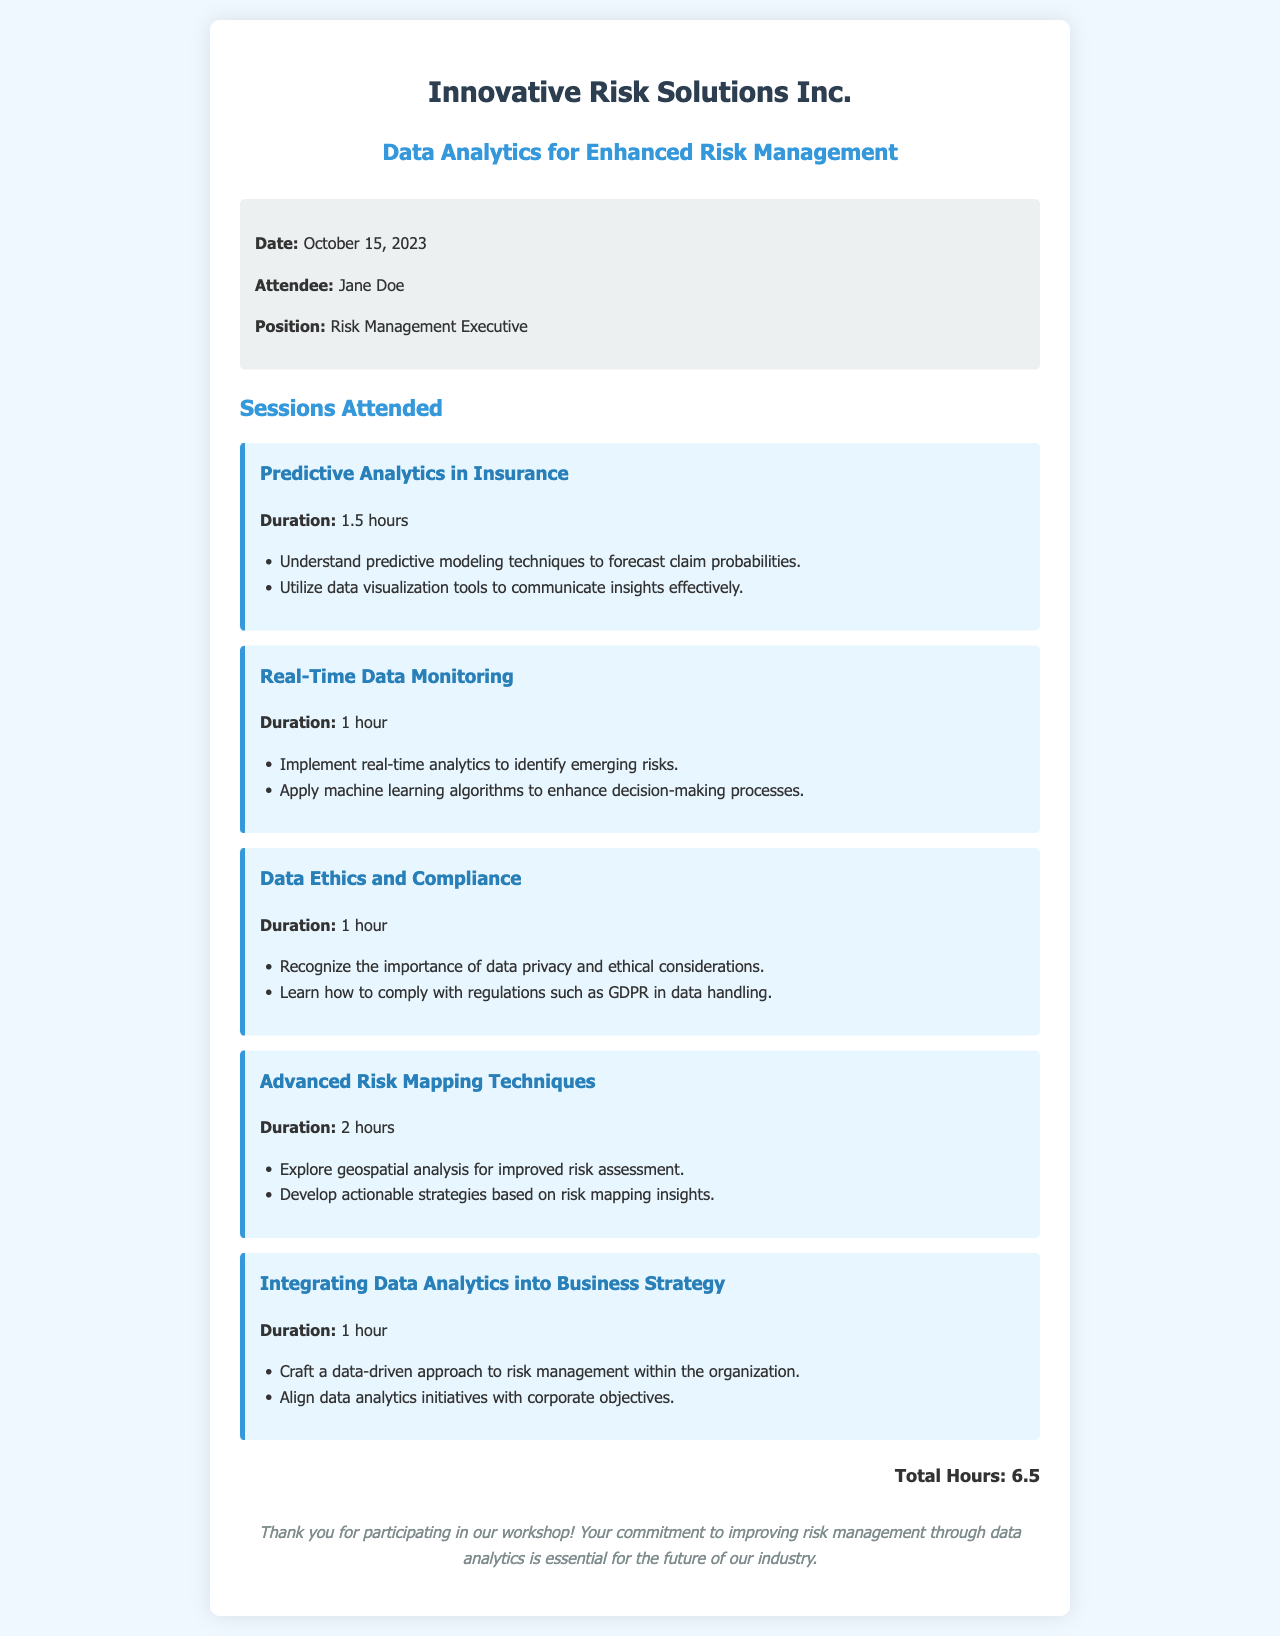What is the date of the workshop? The date of the workshop is stated in the document.
Answer: October 15, 2023 Who is the attendee? The attendee's name is listed in the receipt.
Answer: Jane Doe What position does the attendee hold? The attendee's position is outlined in the information section.
Answer: Risk Management Executive How many hours did the attendee spend in total at the workshop? The total hours are summarized in the document at the end.
Answer: 6.5 What was the duration of the session on Predictive Analytics in Insurance? The duration for each session is provided in the individual session details.
Answer: 1.5 hours Which session covers data privacy and ethical considerations? The session titles signify the topic covered, allowing identification of the relevant session.
Answer: Data Ethics and Compliance What is one key learning outcome from the Advanced Risk Mapping Techniques session? Each session lists specific outcomes that attendees can expect to learn.
Answer: Explore geospatial analysis for improved risk assessment How does the session on Integrating Data Analytics into Business Strategy aim to impact risk management? The learning outcomes indicate how sessions contribute to risk management strategies.
Answer: Craft a data-driven approach to risk management within the organization What color is used for the session titles? The style and color for headings are specified in the document design.
Answer: Blue 